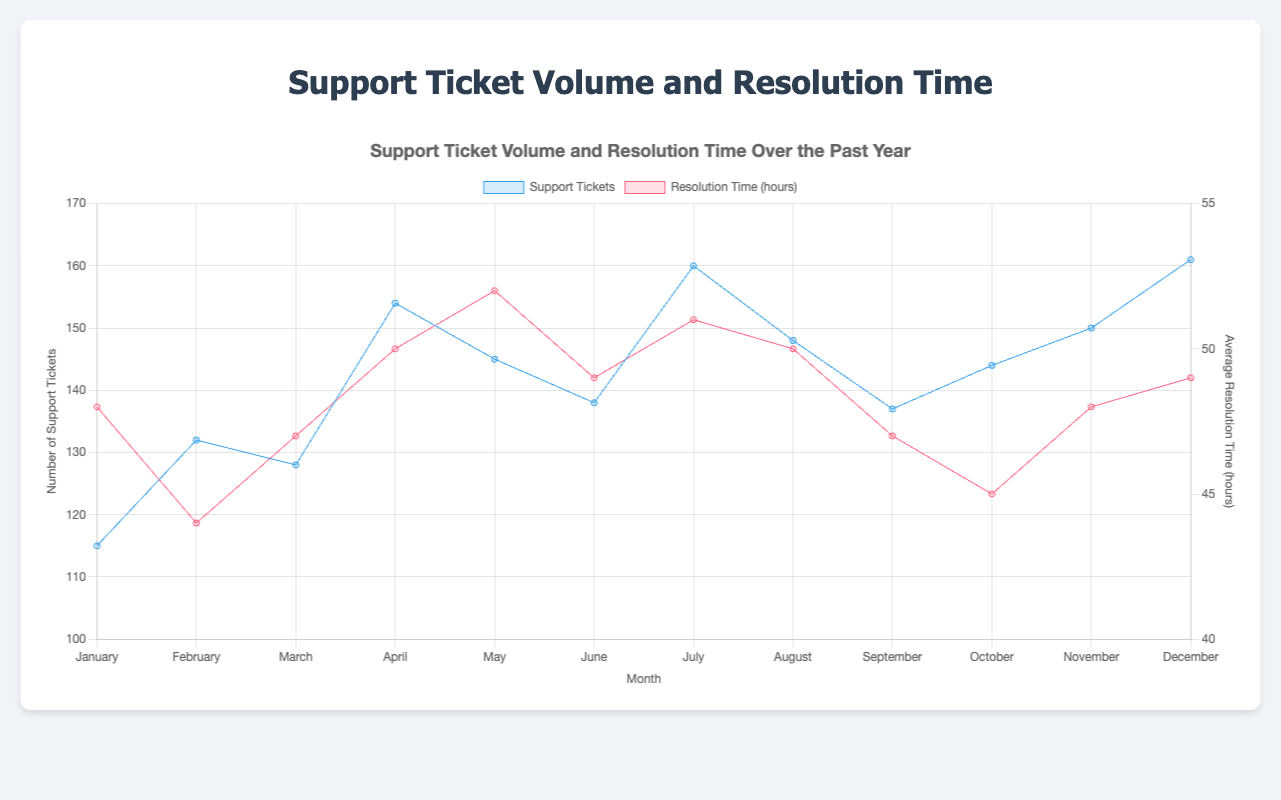Does the support ticket volume increase or decrease from January to December? The chart shows the trend of support tickets from January to December. By observing the chart, we can see that the number of support tickets steadily increases from 115 in January to 161 in December.
Answer: Increase What's the average resolution time in May? The average resolution time for each month is displayed on the chart. The resolution time in May is 52 hours.
Answer: 52 hours Which month has the highest resolution time? By examining the resolution time data line, we can see that May has the highest average resolution time, which is 52 hours.
Answer: May By how much does the resolution time in September differ from that in July? The resolution time in September is 47 hours and in July, it is 51 hours. The difference can be calculated as 51 hours - 47 hours = 4 hours.
Answer: 4 hours Which month had the lowest number of support tickets? We need to look at the months and compare the support ticket numbers. The month with the lowest number is January with 115 tickets.
Answer: January How does the trend of support tickets compare to the trend of resolution time? Observing the overall trends, support ticket volume shows an increasing trend towards the year-end, while the resolution time fluctuates with peaks and valleys but does not show a clear increasing or decreasing trend over the year.
Answer: Support tickets increase, resolution time fluctuates During which month did the volume of support tickets and average resolution times both increase compared to the previous month? We need to check for months where both support tickets and resolution time are higher than the previous month. From January to February, both support tickets (115 to 132) and resolution time (48 to 44) do not increase. From April to May, both support tickets (154 to 145) and resolution time (50 to 52) show an increase, but the ticket volume decreases. Therefore, there is no such month.
Answer: None What is the average number of support tickets over the entire year? Sum of total support tickets for each month: 115 + 132 + 128 + 154 + 145 + 138 + 160 + 148 + 137 + 144 + 150 + 161 = 1712. The average is calculated by dividing 1712 by 12 months which is approximately 142.67.
Answer: 142.67 What are the support ticket volumes for the first and last months compared to their respective resolution times? January has 115 tickets with a resolution time of 48 hours. December has 161 tickets with a resolution time of 49 hours.
Answer: January: 115 tickets, 48 hours; December: 161 tickets, 49 hours How many months have a ticket volume higher than the mean for the entire year? The mean number of tickets for the year is approximately 142.67. The months with higher ticket volume are April (154), July (160), August (148), November (150), and December (161). This gives us 5 months.
Answer: 5 months 